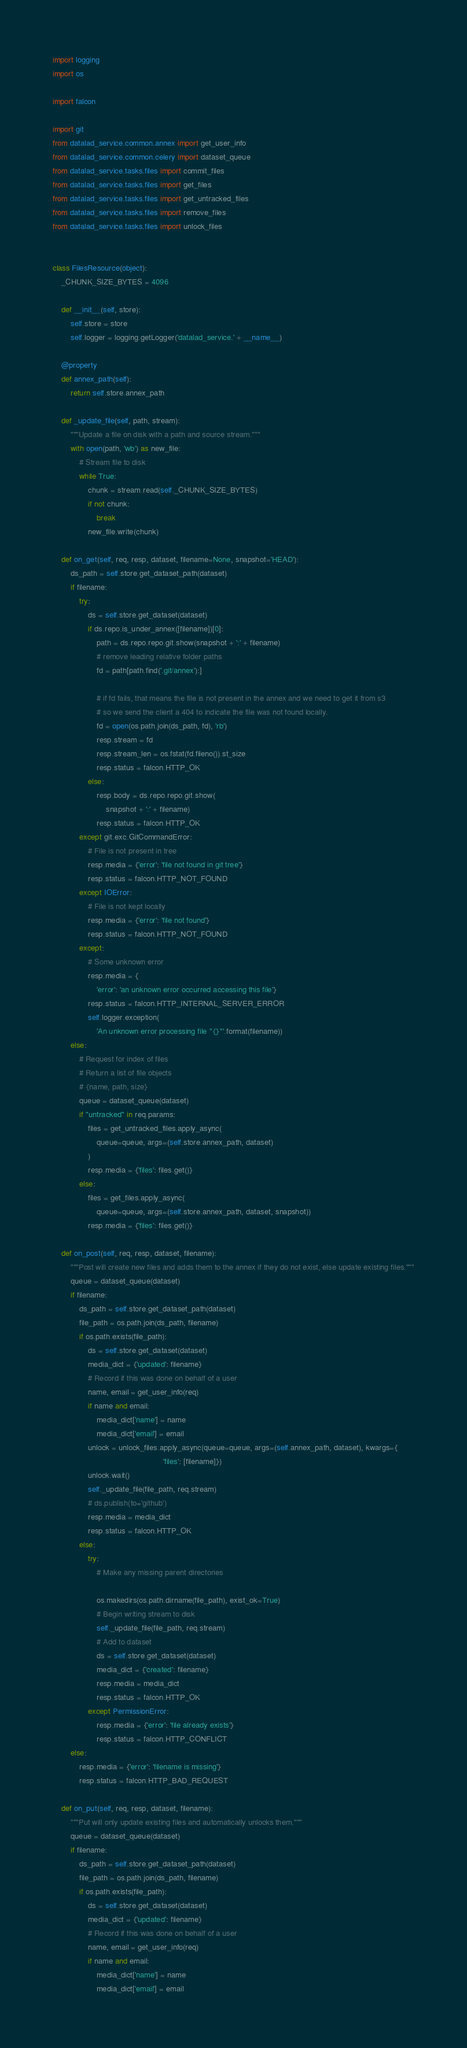<code> <loc_0><loc_0><loc_500><loc_500><_Python_>import logging
import os

import falcon

import git
from datalad_service.common.annex import get_user_info
from datalad_service.common.celery import dataset_queue
from datalad_service.tasks.files import commit_files
from datalad_service.tasks.files import get_files
from datalad_service.tasks.files import get_untracked_files
from datalad_service.tasks.files import remove_files
from datalad_service.tasks.files import unlock_files


class FilesResource(object):
    _CHUNK_SIZE_BYTES = 4096

    def __init__(self, store):
        self.store = store
        self.logger = logging.getLogger('datalad_service.' + __name__)

    @property
    def annex_path(self):
        return self.store.annex_path

    def _update_file(self, path, stream):
        """Update a file on disk with a path and source stream."""
        with open(path, 'wb') as new_file:
            # Stream file to disk
            while True:
                chunk = stream.read(self._CHUNK_SIZE_BYTES)
                if not chunk:
                    break
                new_file.write(chunk)

    def on_get(self, req, resp, dataset, filename=None, snapshot='HEAD'):
        ds_path = self.store.get_dataset_path(dataset)
        if filename:
            try:
                ds = self.store.get_dataset(dataset)
                if ds.repo.is_under_annex([filename])[0]:
                    path = ds.repo.repo.git.show(snapshot + ':' + filename)
                    # remove leading relative folder paths
                    fd = path[path.find('.git/annex'):]

                    # if fd fails, that means the file is not present in the annex and we need to get it from s3
                    # so we send the client a 404 to indicate the file was not found locally.
                    fd = open(os.path.join(ds_path, fd), 'rb')
                    resp.stream = fd
                    resp.stream_len = os.fstat(fd.fileno()).st_size
                    resp.status = falcon.HTTP_OK
                else:
                    resp.body = ds.repo.repo.git.show(
                        snapshot + ':' + filename)
                    resp.status = falcon.HTTP_OK
            except git.exc.GitCommandError:
                # File is not present in tree
                resp.media = {'error': 'file not found in git tree'}
                resp.status = falcon.HTTP_NOT_FOUND
            except IOError:
                # File is not kept locally
                resp.media = {'error': 'file not found'}
                resp.status = falcon.HTTP_NOT_FOUND
            except:
                # Some unknown error
                resp.media = {
                    'error': 'an unknown error occurred accessing this file'}
                resp.status = falcon.HTTP_INTERNAL_SERVER_ERROR
                self.logger.exception(
                    'An unknown error processing file "{}"'.format(filename))
        else:
            # Request for index of files
            # Return a list of file objects
            # {name, path, size}
            queue = dataset_queue(dataset)
            if "untracked" in req.params:
                files = get_untracked_files.apply_async(
                    queue=queue, args=(self.store.annex_path, dataset)
                )
                resp.media = {'files': files.get()}
            else:
                files = get_files.apply_async(
                    queue=queue, args=(self.store.annex_path, dataset, snapshot))
                resp.media = {'files': files.get()}

    def on_post(self, req, resp, dataset, filename):
        """Post will create new files and adds them to the annex if they do not exist, else update existing files."""
        queue = dataset_queue(dataset)
        if filename:
            ds_path = self.store.get_dataset_path(dataset)
            file_path = os.path.join(ds_path, filename)
            if os.path.exists(file_path):
                ds = self.store.get_dataset(dataset)
                media_dict = {'updated': filename}
                # Record if this was done on behalf of a user
                name, email = get_user_info(req)
                if name and email:
                    media_dict['name'] = name
                    media_dict['email'] = email
                unlock = unlock_files.apply_async(queue=queue, args=(self.annex_path, dataset), kwargs={
                                                  'files': [filename]})
                unlock.wait()
                self._update_file(file_path, req.stream)
                # ds.publish(to='github')
                resp.media = media_dict
                resp.status = falcon.HTTP_OK
            else:
                try:
                    # Make any missing parent directories

                    os.makedirs(os.path.dirname(file_path), exist_ok=True)
                    # Begin writing stream to disk
                    self._update_file(file_path, req.stream)
                    # Add to dataset
                    ds = self.store.get_dataset(dataset)
                    media_dict = {'created': filename}
                    resp.media = media_dict
                    resp.status = falcon.HTTP_OK
                except PermissionError:
                    resp.media = {'error': 'file already exists'}
                    resp.status = falcon.HTTP_CONFLICT
        else:
            resp.media = {'error': 'filename is missing'}
            resp.status = falcon.HTTP_BAD_REQUEST

    def on_put(self, req, resp, dataset, filename):
        """Put will only update existing files and automatically unlocks them."""
        queue = dataset_queue(dataset)
        if filename:
            ds_path = self.store.get_dataset_path(dataset)
            file_path = os.path.join(ds_path, filename)
            if os.path.exists(file_path):
                ds = self.store.get_dataset(dataset)
                media_dict = {'updated': filename}
                # Record if this was done on behalf of a user
                name, email = get_user_info(req)
                if name and email:
                    media_dict['name'] = name
                    media_dict['email'] = email</code> 